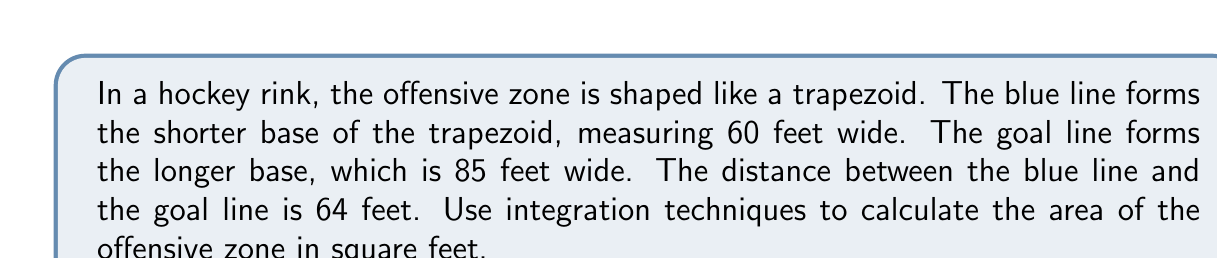Could you help me with this problem? Let's approach this step-by-step:

1) First, we need to set up a coordinate system. Let's place the origin at the center of the blue line, with the x-axis along the length of the zone and the y-axis along the width.

2) The equation of a straight line in this trapezoid can be written as:

   $$y = mx + b$$

   where $m$ is the slope and $b$ is the y-intercept.

3) We can find the slope by calculating the change in width over the change in length:

   $$m = \frac{85/2 - 60/2}{64} = \frac{25/2}{64} = \frac{25}{128}$$

4) The equation for the right side of the trapezoid is:

   $$y = \frac{25}{128}x + 30$$

   (The y-intercept is 30 because that's half the width of the blue line)

5) To find the area, we'll integrate this function from 0 to 64 and double the result (since we're only calculating half of the trapezoid):

   $$A = 2 \int_0^{64} (\frac{25}{128}x + 30) dx$$

6) Integrating:

   $$A = 2 [\frac{25}{256}x^2 + 30x]_0^{64}$$

7) Evaluating the integral:

   $$A = 2 [(\frac{25}{256}(64^2) + 30(64)) - (\frac{25}{256}(0^2) + 30(0))]$$
   $$A = 2 [400 + 1920]$$
   $$A = 2(2320)$$
   $$A = 4640$$

Therefore, the area of the offensive zone is 4640 square feet.
Answer: 4640 sq ft 